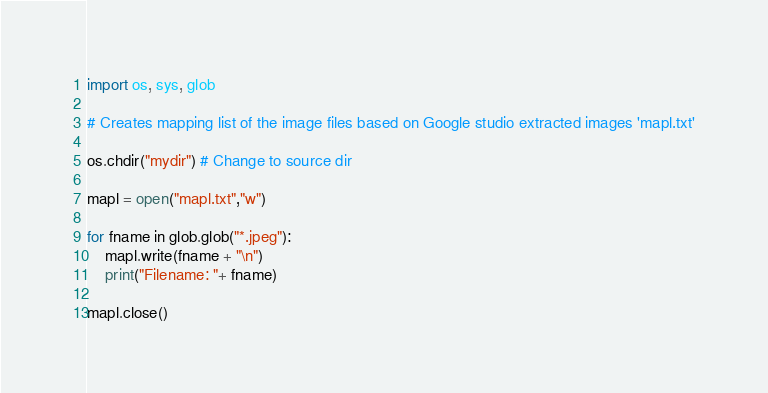<code> <loc_0><loc_0><loc_500><loc_500><_Python_>import os, sys, glob

# Creates mapping list of the image files based on Google studio extracted images 'mapl.txt'

os.chdir("mydir") # Change to source dir

mapl = open("mapl.txt","w")

for fname in glob.glob("*.jpeg"):
    mapl.write(fname + "\n")
    print("Filename: "+ fname)

mapl.close()
</code> 